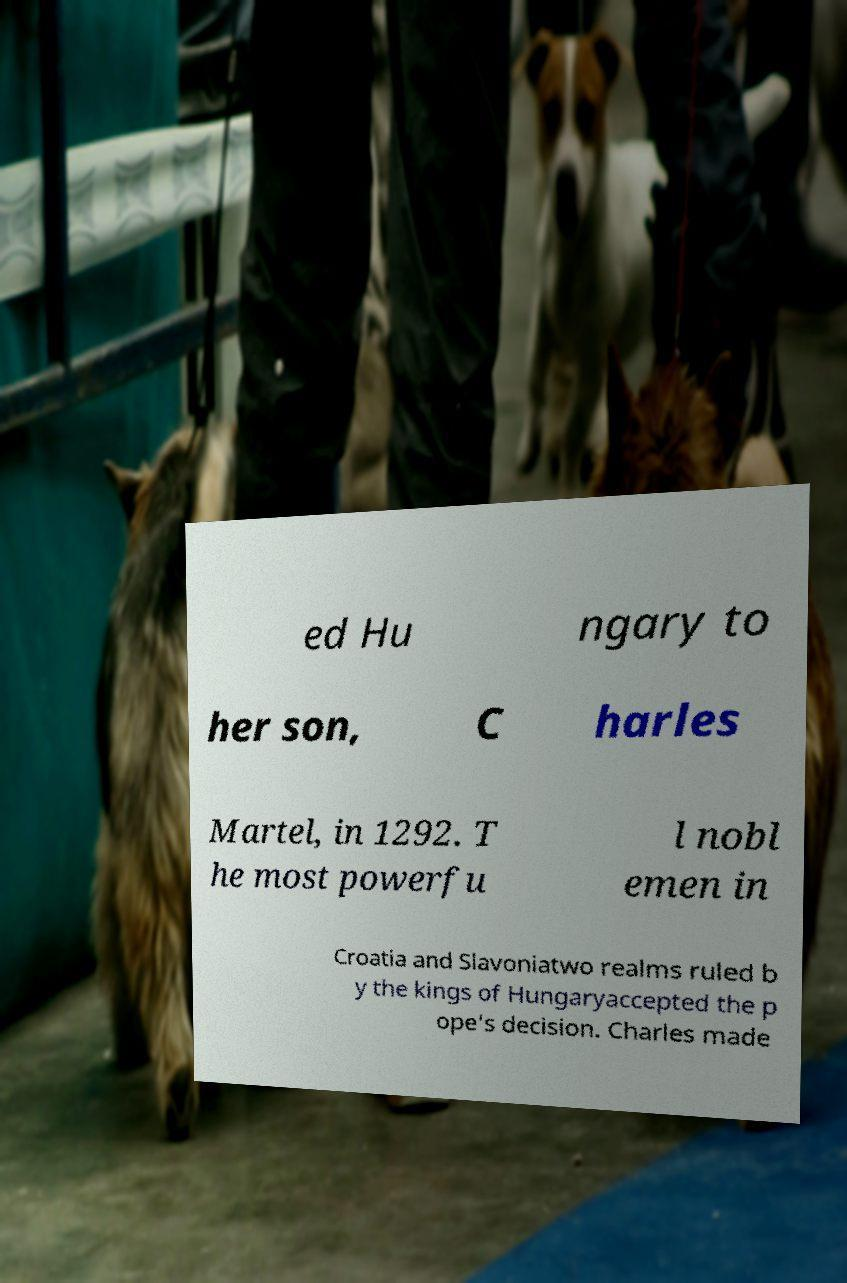Please identify and transcribe the text found in this image. ed Hu ngary to her son, C harles Martel, in 1292. T he most powerfu l nobl emen in Croatia and Slavoniatwo realms ruled b y the kings of Hungaryaccepted the p ope's decision. Charles made 